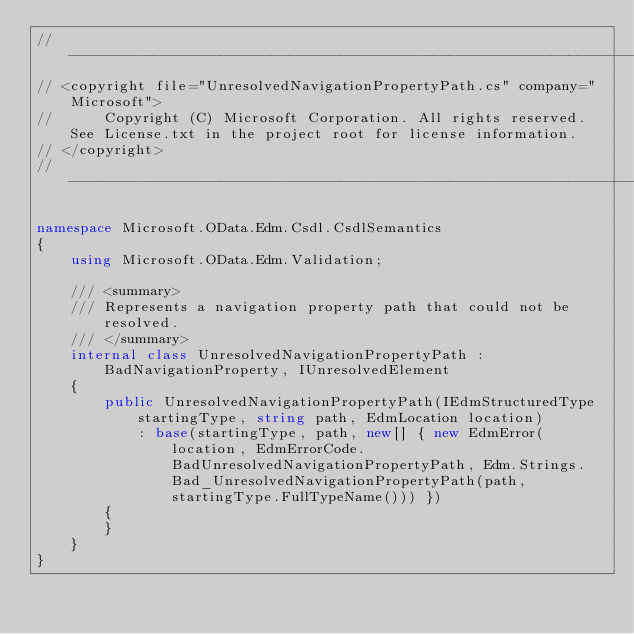<code> <loc_0><loc_0><loc_500><loc_500><_C#_>//---------------------------------------------------------------------
// <copyright file="UnresolvedNavigationPropertyPath.cs" company="Microsoft">
//      Copyright (C) Microsoft Corporation. All rights reserved. See License.txt in the project root for license information.
// </copyright>
//---------------------------------------------------------------------

namespace Microsoft.OData.Edm.Csdl.CsdlSemantics
{
    using Microsoft.OData.Edm.Validation;

    /// <summary>
    /// Represents a navigation property path that could not be resolved.
    /// </summary>
    internal class UnresolvedNavigationPropertyPath : BadNavigationProperty, IUnresolvedElement
    {
        public UnresolvedNavigationPropertyPath(IEdmStructuredType startingType, string path, EdmLocation location)
            : base(startingType, path, new[] { new EdmError(location, EdmErrorCode.BadUnresolvedNavigationPropertyPath, Edm.Strings.Bad_UnresolvedNavigationPropertyPath(path, startingType.FullTypeName())) })
        {
        }
    }
}
</code> 